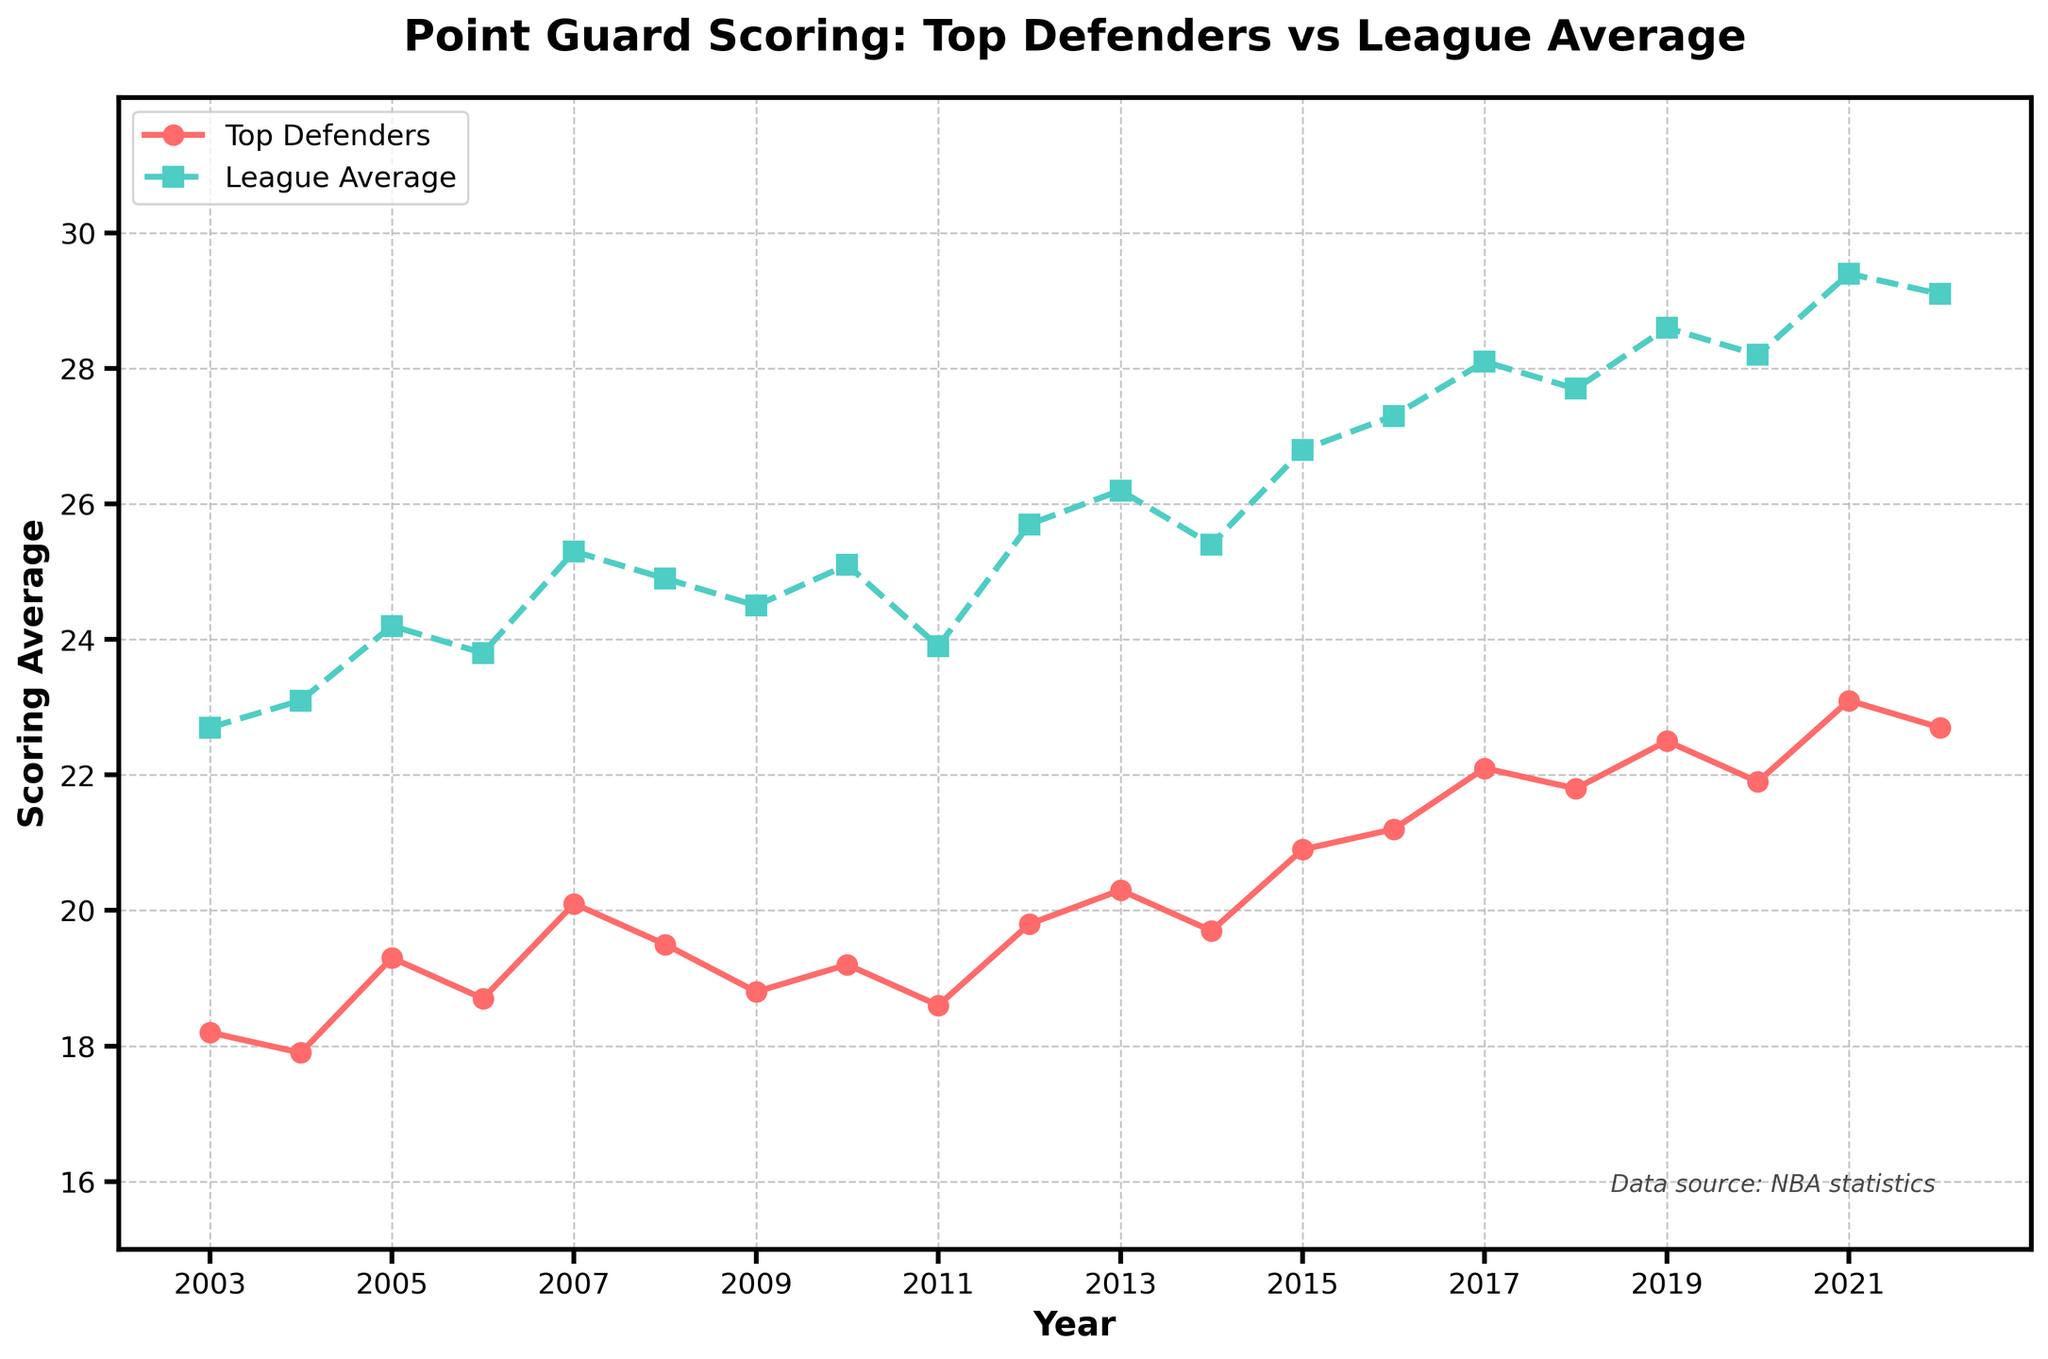What year shows the largest difference between top defenders' scoring average and the league average? To find the largest difference, we need to calculate the difference between the league average and the top defenders' average for each year, then identify the year with the maximum difference. The differences are: 4.5 (2003), 5.2 (2004), 4.9 (2005), 5.1 (2006), 5.2 (2007), 5.4 (2008), 5.7 (2009), 5.9 (2010), 5.3 (2011), 5.9 (2012), 5.9 (2013), 5.7 (2014), 5.9 (2015), 6.1 (2016), 6.0 (2017), 5.9 (2018), 6.1 (2019), 6.3 (2020), 6.3 (2021), and 6.4 (2022). The largest difference is 6.4 in 2022.
Answer: 2022 Which year had the lowest scoring average for point guards against top defenders? We need to look for the lowest value on the "Top Defenders" line. From the figure, the lowest point on the top defenders' line is 17.9 in the year 2004.
Answer: 2004 How have the scoring averages against top defenders and league averages trended from 2003 to 2022? This requires identifying the overall direction of both lines from the start to the end of the period. The top defenders' line shows an increasing trend, starting from 18.2 in 2003 to 22.7 in 2022. Similarly, the league average also shows an increasing trend from 22.7 in 2003 to 29.1 in 2022. Both trends are upwards.
Answer: Both are increasing During which years did point guards playing against top defenders score more than 21 points on average? Reviewing the "Top Defenders" line, we find averages above 21 points in 2016 (21.2), 2017 (22.1), 2018 (21.8), 2019 (22.5), 2020 (21.9), 2021 (23.1), and 2022 (22.7).
Answer: 2016, 2017, 2018, 2019, 2020, 2021, 2022 What is the average scoring difference between league average and top defenders over the 20 years? To find the average difference, first calculate the yearly differences, then find their mean: (4.5 + 5.2 + 4.9 + 5.1 + 5.2 + 5.4 + 5.7 + 5.9 + 5.3 + 5.9 + 5.9 + 5.7 + 5.9 + 6.1 + 6.0 + 5.9 + 6.1 + 6.3 + 6.3 + 6.4) / 20 = 5.75.
Answer: 5.75 points In which years did the scoring average against top defenders exceed the previous year's average? We need to compare each year's score against the previous year's score: 2005 (19.3 > 17.9), 2007 (20.1 > 18.7), 2008 (19.5 < 20.1), 2010 (19.2 > 18.8), 2012 (19.8 > 18.6), 2013 (20.3 > 19.8), 2015 (20.9 > 19.7), 2016 (21.2 > 20.9), 2017 (22.1 > 21.2), 2019 (22.5 > 21.8), 2021 (23.1 > 21.9).
Answer: 2005, 2007, 2010, 2012, 2013, 2015, 2016, 2017, 2019, 2021 